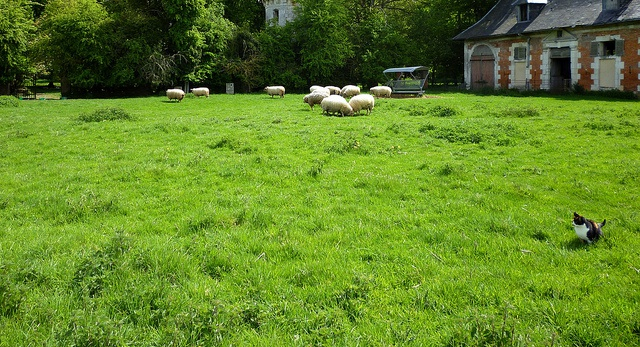Describe the objects in this image and their specific colors. I can see cat in olive, black, darkgray, gray, and darkgreen tones, sheep in olive, ivory, and darkgreen tones, sheep in olive, ivory, and beige tones, sheep in olive, white, darkgreen, black, and gray tones, and sheep in olive, darkgreen, and ivory tones in this image. 